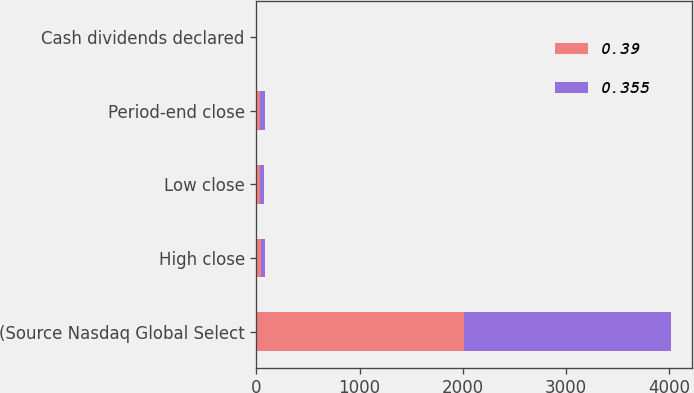Convert chart to OTSL. <chart><loc_0><loc_0><loc_500><loc_500><stacked_bar_chart><ecel><fcel>(Source Nasdaq Global Select<fcel>High close<fcel>Low close<fcel>Period-end close<fcel>Cash dividends declared<nl><fcel>0.39<fcel>2008<fcel>39.71<fcel>35.1<fcel>38.04<fcel>0.39<nl><fcel>0.355<fcel>2007<fcel>45.92<fcel>42.24<fcel>42.4<fcel>0.35<nl></chart> 